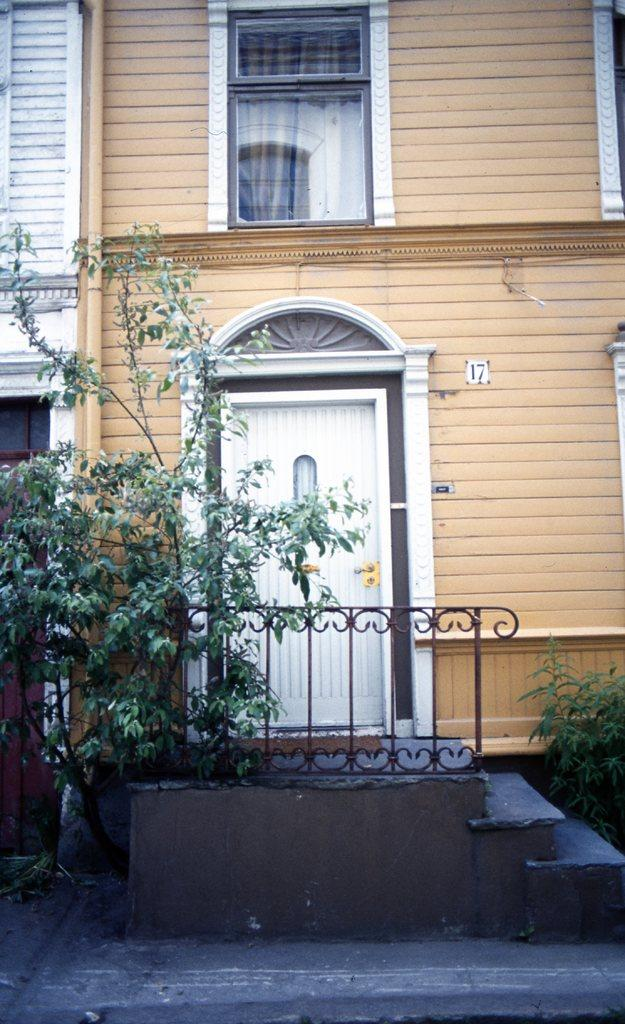What type of structure is present in the image? There is a building in the image. What is a feature of the building that allows access? There is a door in the image. What type of material is used for the window in the building? There is a glass window in the image. What can be seen on the left side of the image? There is a tree on the left side of the image. How can one access the upper levels of the building? There are stairs visible in the image. What type of shirt is the creature wearing in the image? There is no creature present in the image, and therefore no shirt or creature can be observed. 